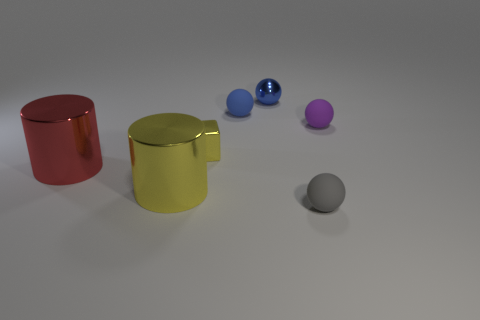Subtract all tiny blue matte spheres. How many spheres are left? 3 Add 1 big red rubber spheres. How many objects exist? 8 Subtract all blue spheres. How many spheres are left? 2 Subtract all cylinders. How many objects are left? 5 Subtract all yellow cubes. How many yellow cylinders are left? 1 Add 7 purple matte objects. How many purple matte objects exist? 8 Subtract 1 yellow blocks. How many objects are left? 6 Subtract 3 balls. How many balls are left? 1 Subtract all brown blocks. Subtract all green spheres. How many blocks are left? 1 Subtract all tiny spheres. Subtract all tiny blue shiny things. How many objects are left? 2 